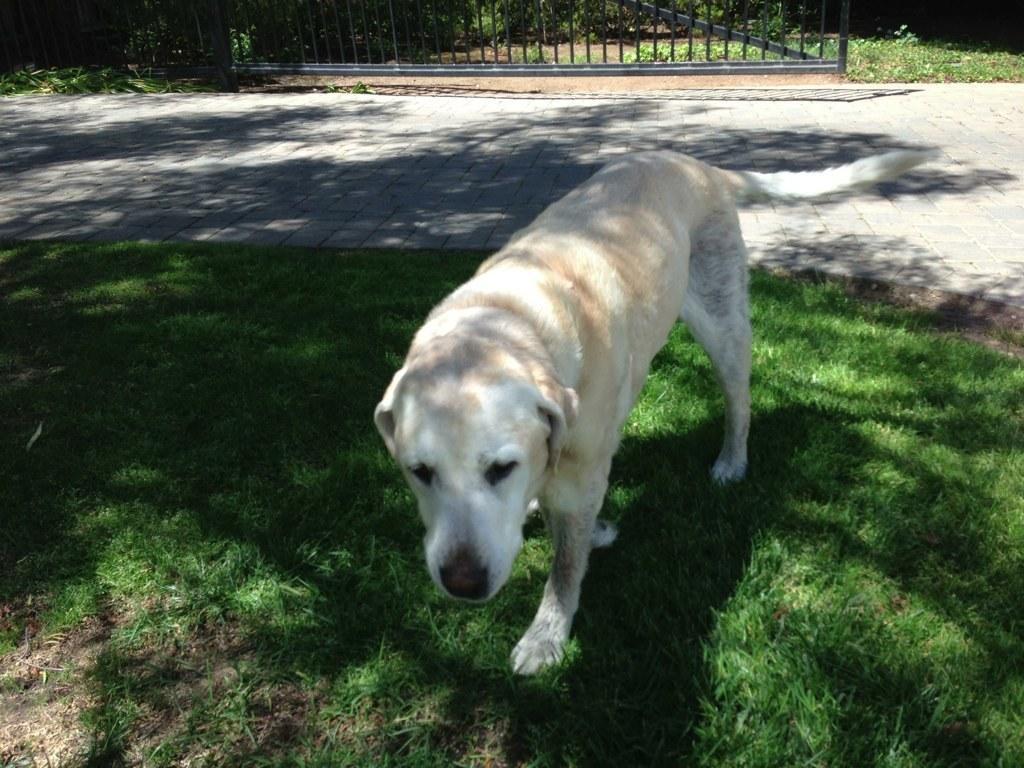Can you describe this image briefly? This image consists of a dog in white color. At the bottom, there is green grass. In the background, there is a fencing. And we can see a road. 